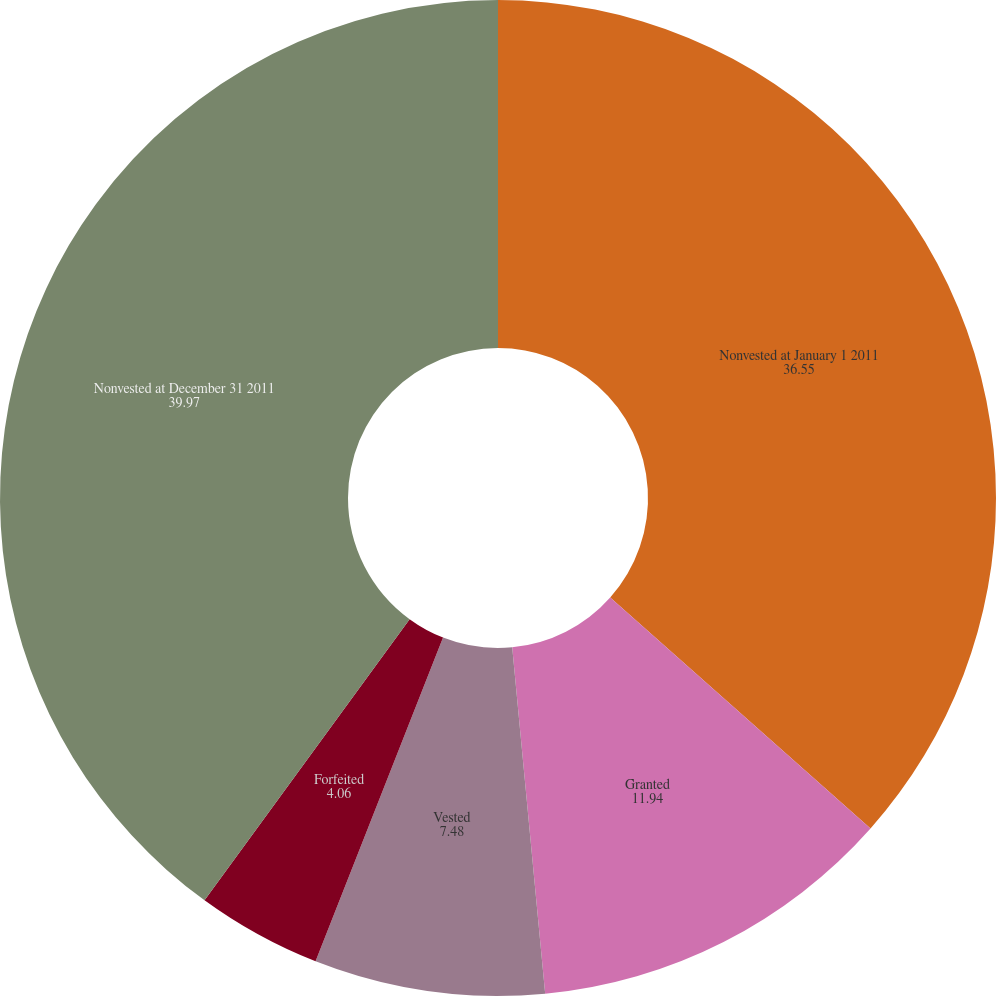<chart> <loc_0><loc_0><loc_500><loc_500><pie_chart><fcel>Nonvested at January 1 2011<fcel>Granted<fcel>Vested<fcel>Forfeited<fcel>Nonvested at December 31 2011<nl><fcel>36.55%<fcel>11.94%<fcel>7.48%<fcel>4.06%<fcel>39.97%<nl></chart> 